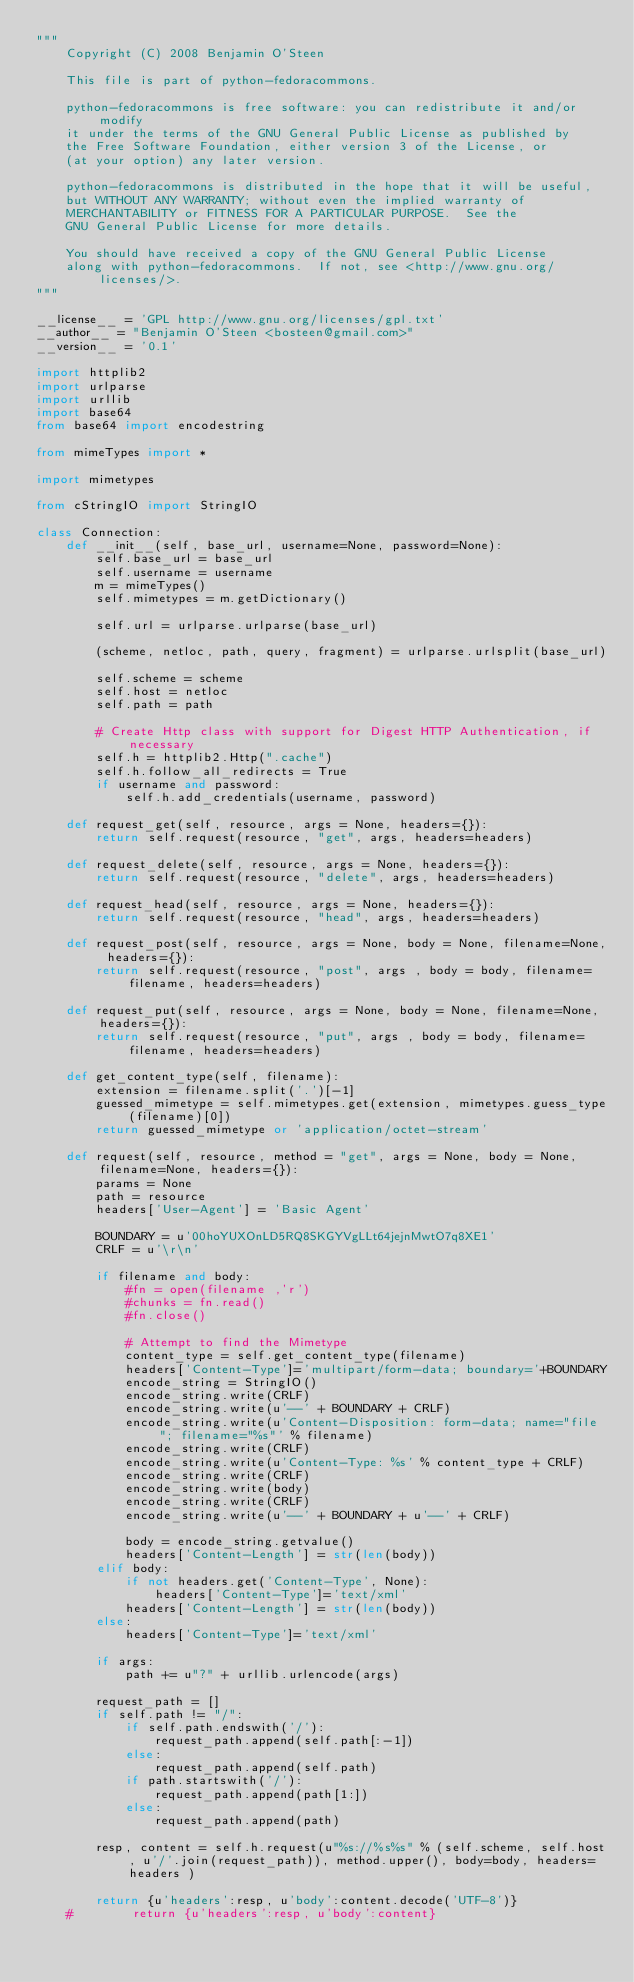<code> <loc_0><loc_0><loc_500><loc_500><_Python_>"""
    Copyright (C) 2008 Benjamin O'Steen

    This file is part of python-fedoracommons.

    python-fedoracommons is free software: you can redistribute it and/or modify
    it under the terms of the GNU General Public License as published by
    the Free Software Foundation, either version 3 of the License, or
    (at your option) any later version.

    python-fedoracommons is distributed in the hope that it will be useful,
    but WITHOUT ANY WARRANTY; without even the implied warranty of
    MERCHANTABILITY or FITNESS FOR A PARTICULAR PURPOSE.  See the
    GNU General Public License for more details.

    You should have received a copy of the GNU General Public License
    along with python-fedoracommons.  If not, see <http://www.gnu.org/licenses/>.
"""

__license__ = 'GPL http://www.gnu.org/licenses/gpl.txt'
__author__ = "Benjamin O'Steen <bosteen@gmail.com>"
__version__ = '0.1'

import httplib2
import urlparse
import urllib
import base64
from base64 import encodestring

from mimeTypes import *

import mimetypes

from cStringIO import StringIO

class Connection:
    def __init__(self, base_url, username=None, password=None):
        self.base_url = base_url
        self.username = username
        m = mimeTypes()
        self.mimetypes = m.getDictionary()

        self.url = urlparse.urlparse(base_url)

        (scheme, netloc, path, query, fragment) = urlparse.urlsplit(base_url)

        self.scheme = scheme
        self.host = netloc
        self.path = path

        # Create Http class with support for Digest HTTP Authentication, if necessary
        self.h = httplib2.Http(".cache")
        self.h.follow_all_redirects = True
        if username and password:
            self.h.add_credentials(username, password)

    def request_get(self, resource, args = None, headers={}):
        return self.request(resource, "get", args, headers=headers)

    def request_delete(self, resource, args = None, headers={}):
        return self.request(resource, "delete", args, headers=headers)

    def request_head(self, resource, args = None, headers={}):
        return self.request(resource, "head", args, headers=headers)

    def request_post(self, resource, args = None, body = None, filename=None, headers={}):
        return self.request(resource, "post", args , body = body, filename=filename, headers=headers)

    def request_put(self, resource, args = None, body = None, filename=None, headers={}):
        return self.request(resource, "put", args , body = body, filename=filename, headers=headers)

    def get_content_type(self, filename):
        extension = filename.split('.')[-1]
        guessed_mimetype = self.mimetypes.get(extension, mimetypes.guess_type(filename)[0])
        return guessed_mimetype or 'application/octet-stream'

    def request(self, resource, method = "get", args = None, body = None, filename=None, headers={}):
        params = None
        path = resource
        headers['User-Agent'] = 'Basic Agent'

        BOUNDARY = u'00hoYUXOnLD5RQ8SKGYVgLLt64jejnMwtO7q8XE1'
        CRLF = u'\r\n'

        if filename and body:
            #fn = open(filename ,'r')
            #chunks = fn.read()
            #fn.close()

            # Attempt to find the Mimetype
            content_type = self.get_content_type(filename)
            headers['Content-Type']='multipart/form-data; boundary='+BOUNDARY
            encode_string = StringIO()
            encode_string.write(CRLF)
            encode_string.write(u'--' + BOUNDARY + CRLF)
            encode_string.write(u'Content-Disposition: form-data; name="file"; filename="%s"' % filename)
            encode_string.write(CRLF)
            encode_string.write(u'Content-Type: %s' % content_type + CRLF)
            encode_string.write(CRLF)
            encode_string.write(body)
            encode_string.write(CRLF)
            encode_string.write(u'--' + BOUNDARY + u'--' + CRLF)

            body = encode_string.getvalue()
            headers['Content-Length'] = str(len(body))
        elif body:
            if not headers.get('Content-Type', None):
                headers['Content-Type']='text/xml'
            headers['Content-Length'] = str(len(body))
        else:
            headers['Content-Type']='text/xml'

        if args:
            path += u"?" + urllib.urlencode(args)

        request_path = []
        if self.path != "/":
            if self.path.endswith('/'):
                request_path.append(self.path[:-1])
            else:
                request_path.append(self.path)
            if path.startswith('/'):
                request_path.append(path[1:])
            else:
                request_path.append(path)

        resp, content = self.h.request(u"%s://%s%s" % (self.scheme, self.host, u'/'.join(request_path)), method.upper(), body=body, headers=headers )

        return {u'headers':resp, u'body':content.decode('UTF-8')}
    #        return {u'headers':resp, u'body':content}
</code> 